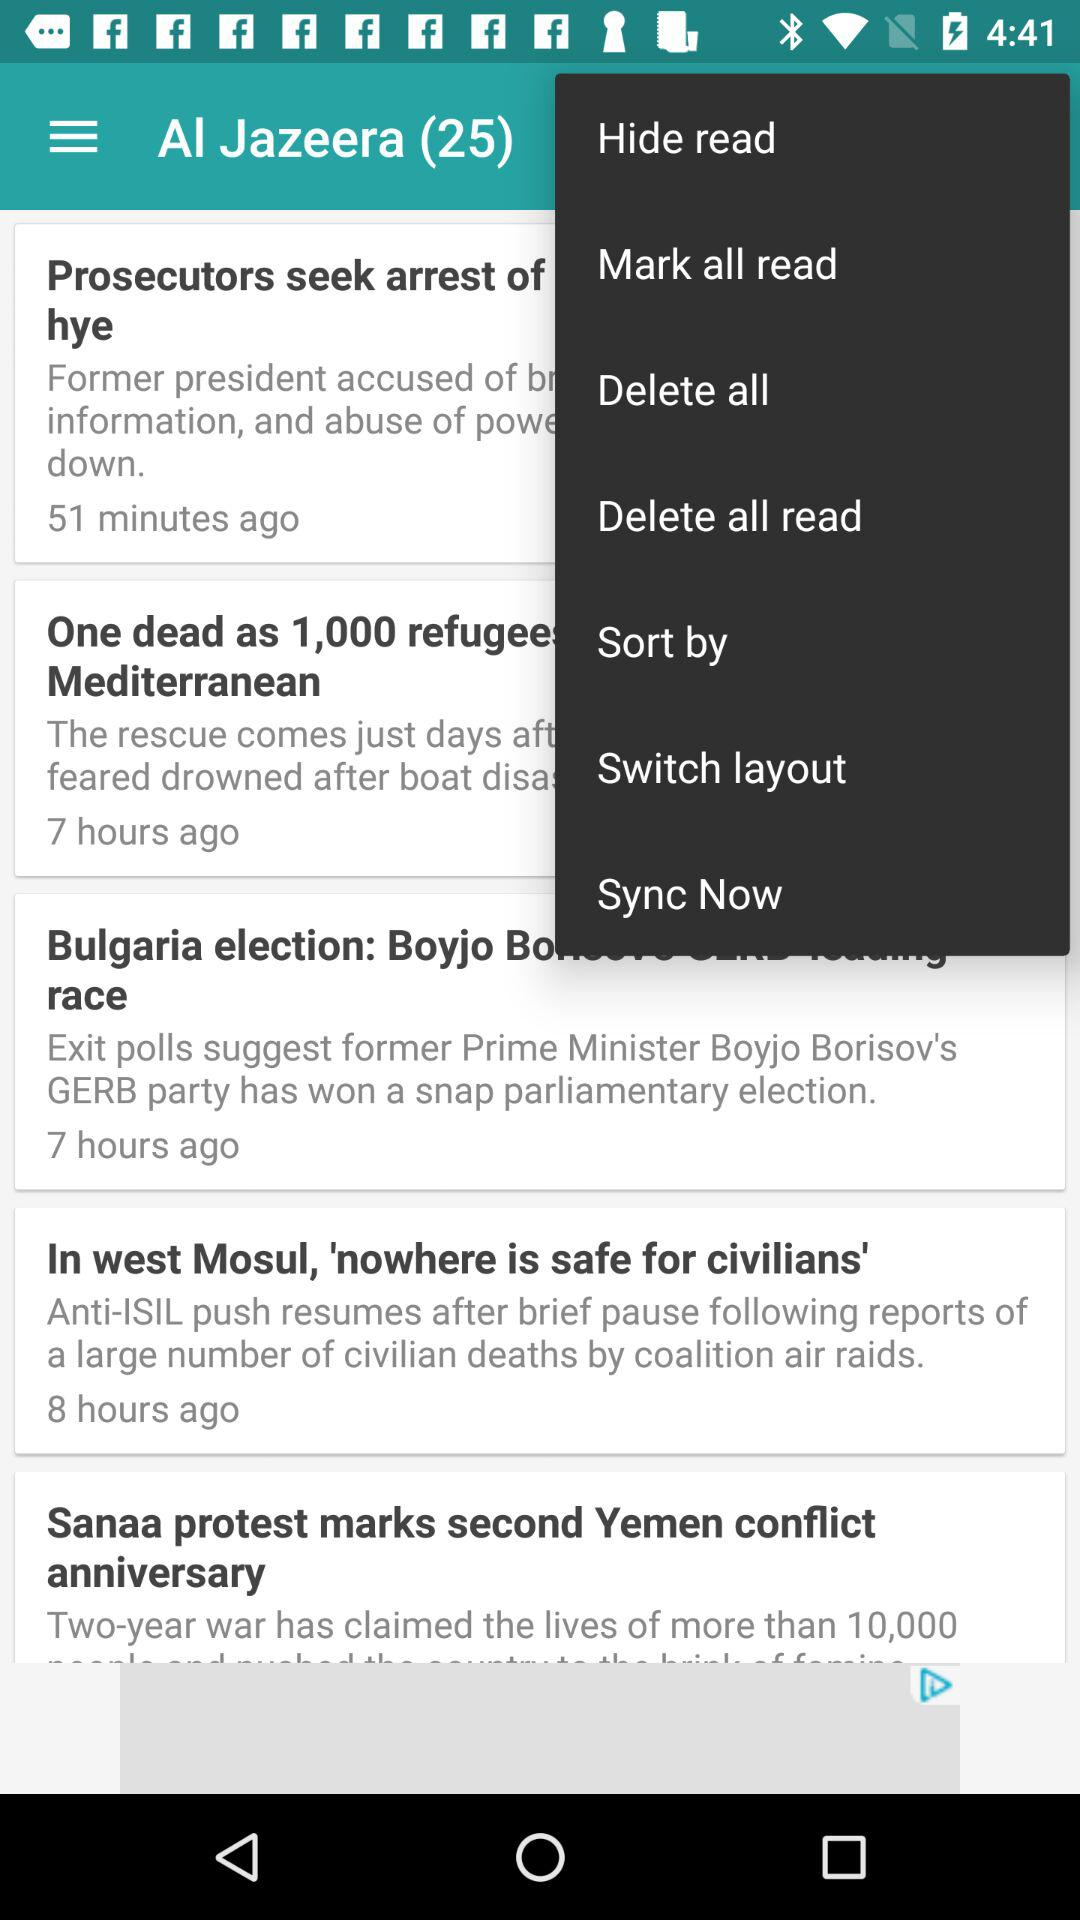How many items are marked as read?
Answer the question using a single word or phrase. 0 